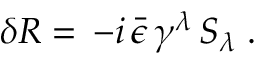<formula> <loc_0><loc_0><loc_500><loc_500>\delta R = \, - i \, \bar { \epsilon } \, \gamma ^ { \lambda } \, S _ { \lambda } \, .</formula> 